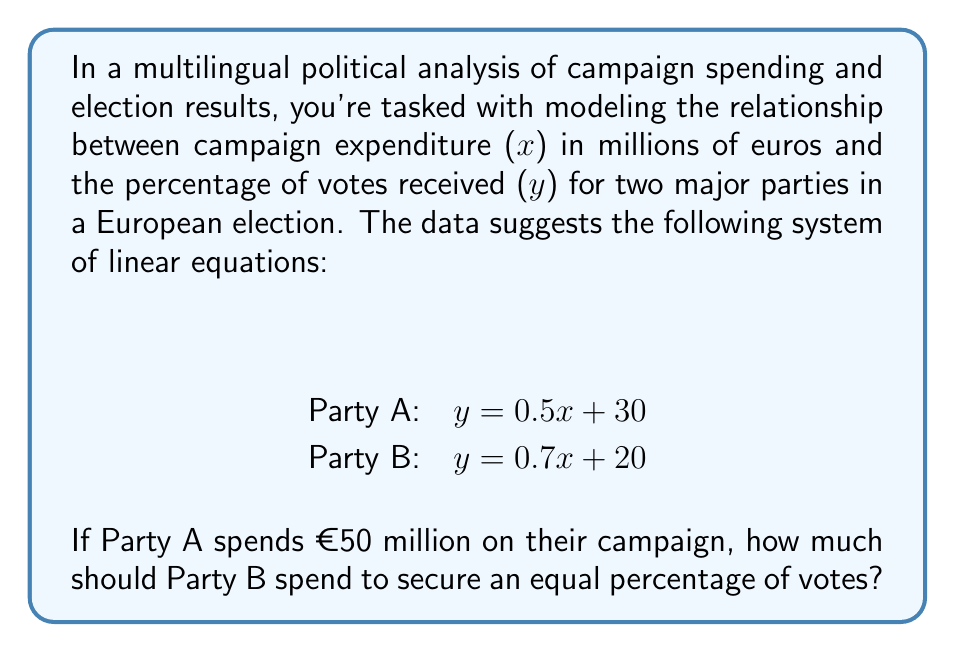Could you help me with this problem? Let's approach this step-by-step:

1) We know that Party A spends €50 million. Let's substitute this into their equation:
   $y_A = 0.5(50) + 30 = 25 + 30 = 55$
   So, Party A will receive 55% of the votes.

2) For Party B to get the same percentage, we need to solve:
   $0.7x + 20 = 55$

3) Let's solve this equation:
   $0.7x = 55 - 20$
   $0.7x = 35$
   $x = 35 / 0.7 = 50$

4) Therefore, Party B needs to spend €50 million to match Party A's vote percentage.

5) We can verify:
   Party B: $y_B = 0.7(50) + 20 = 35 + 20 = 55$

Both parties now have 55% of the votes (in a simplified model where total can exceed 100%).
Answer: €50 million 